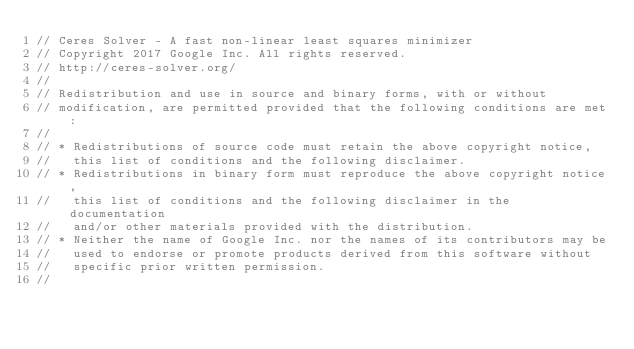<code> <loc_0><loc_0><loc_500><loc_500><_C++_>// Ceres Solver - A fast non-linear least squares minimizer
// Copyright 2017 Google Inc. All rights reserved.
// http://ceres-solver.org/
//
// Redistribution and use in source and binary forms, with or without
// modification, are permitted provided that the following conditions are met:
//
// * Redistributions of source code must retain the above copyright notice,
//   this list of conditions and the following disclaimer.
// * Redistributions in binary form must reproduce the above copyright notice,
//   this list of conditions and the following disclaimer in the documentation
//   and/or other materials provided with the distribution.
// * Neither the name of Google Inc. nor the names of its contributors may be
//   used to endorse or promote products derived from this software without
//   specific prior written permission.
//</code> 